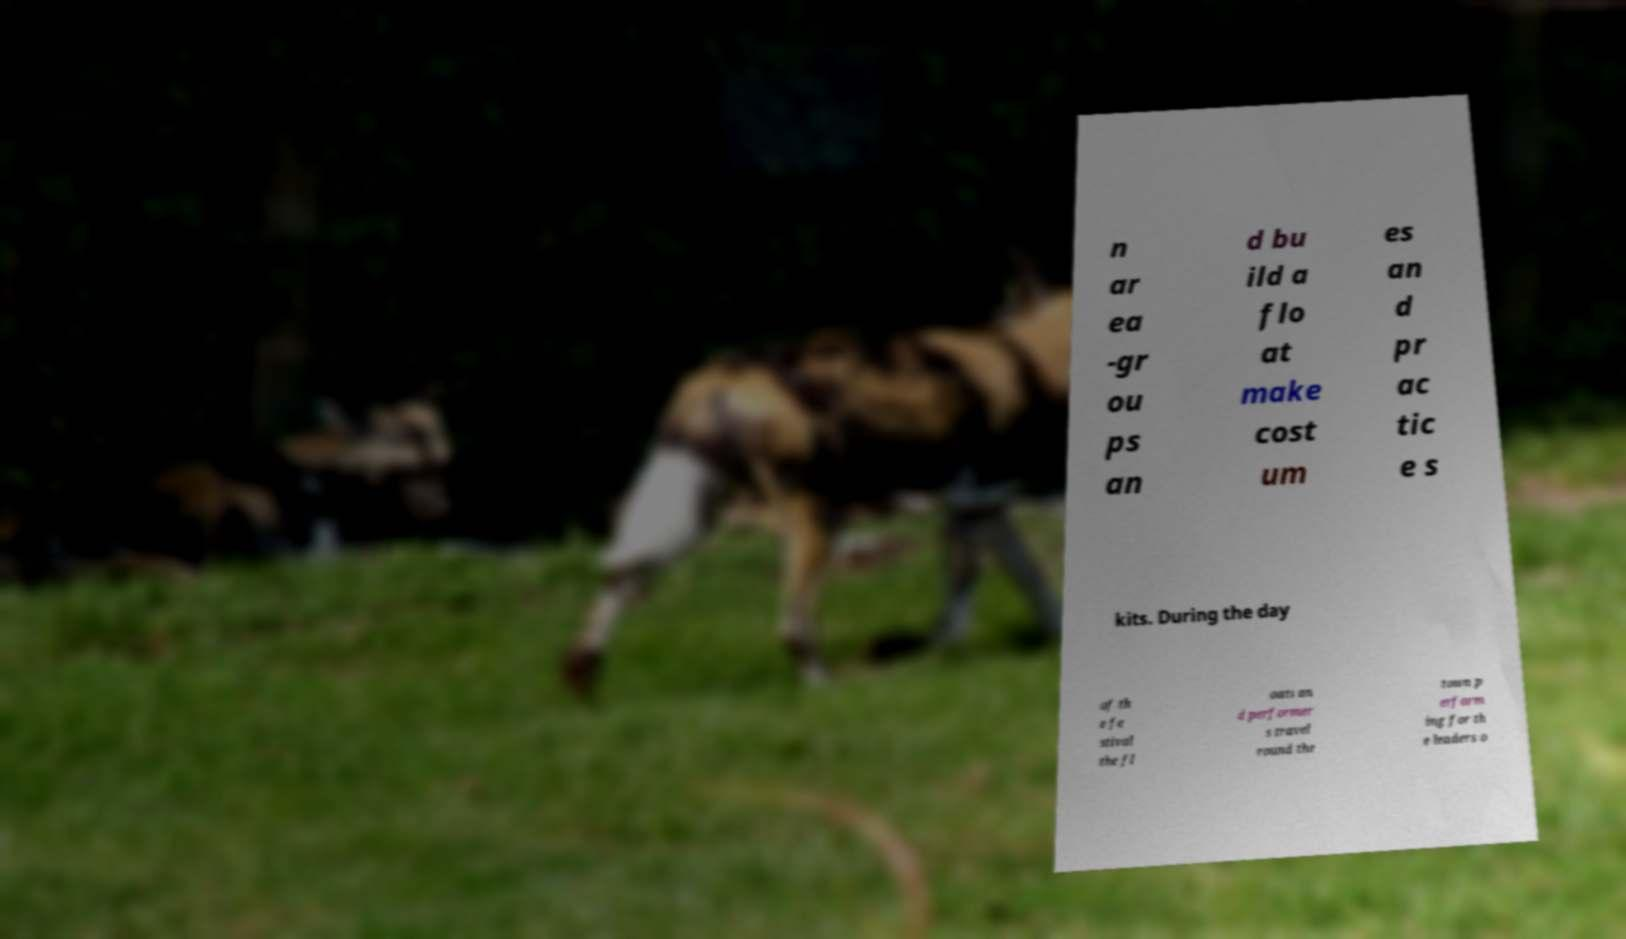There's text embedded in this image that I need extracted. Can you transcribe it verbatim? n ar ea -gr ou ps an d bu ild a flo at make cost um es an d pr ac tic e s kits. During the day of th e fe stival the fl oats an d performer s travel round the town p erform ing for th e leaders o 